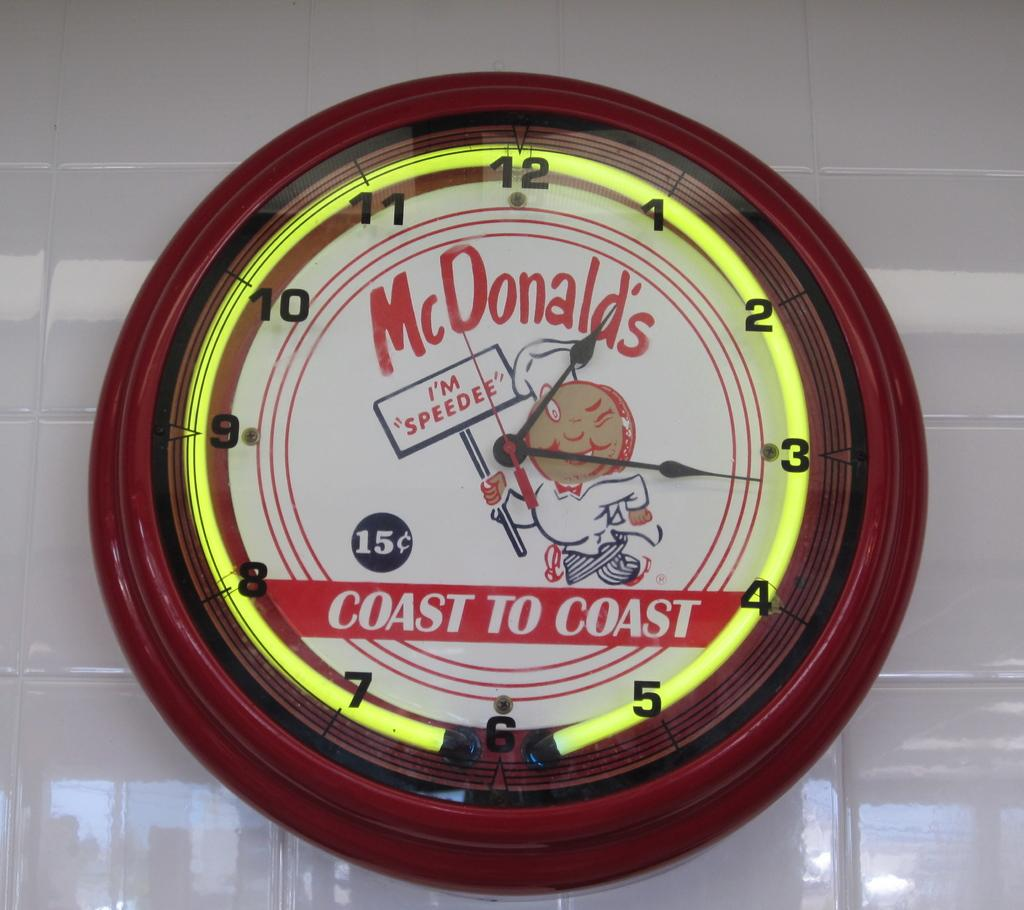<image>
Present a compact description of the photo's key features. A red clock is on a white wall and the clock has the word coast on it. 